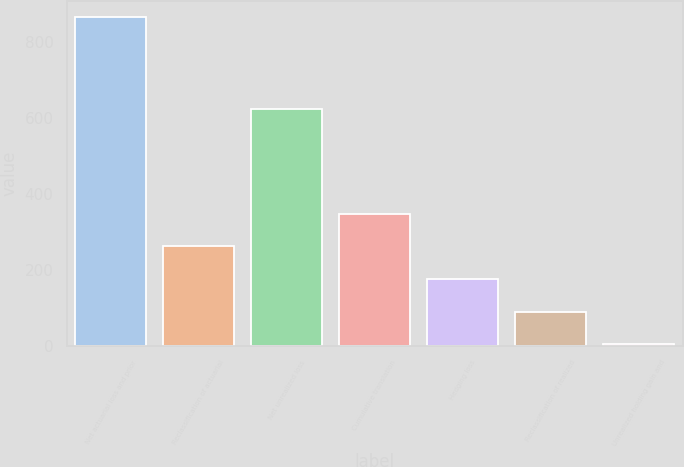Convert chart to OTSL. <chart><loc_0><loc_0><loc_500><loc_500><bar_chart><fcel>Net actuarial loss and prior<fcel>Reclassification of actuarial<fcel>Net unrealized loss<fcel>Cumulative translation<fcel>Hedging loss<fcel>Reclassification of realized<fcel>Unrealized holding gain and<nl><fcel>864<fcel>262.7<fcel>624<fcel>348.6<fcel>176.8<fcel>90.9<fcel>5<nl></chart> 